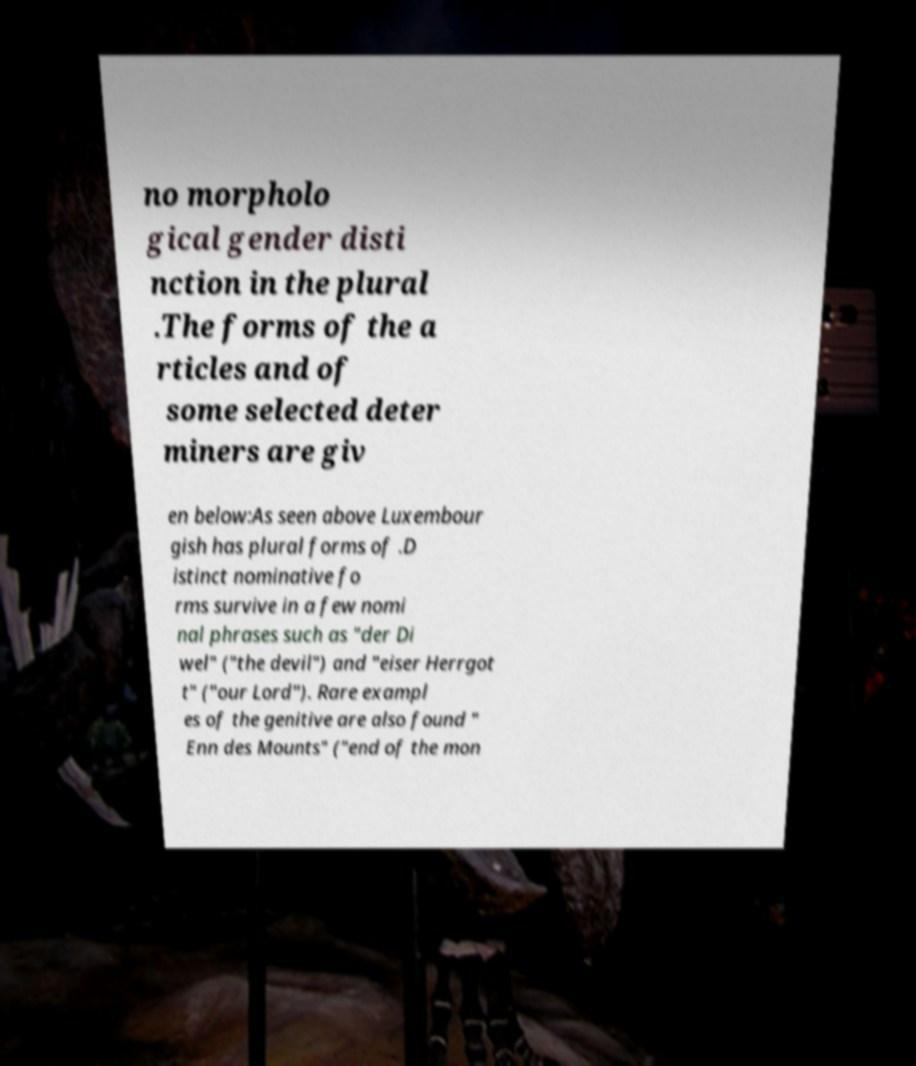What messages or text are displayed in this image? I need them in a readable, typed format. no morpholo gical gender disti nction in the plural .The forms of the a rticles and of some selected deter miners are giv en below:As seen above Luxembour gish has plural forms of .D istinct nominative fo rms survive in a few nomi nal phrases such as "der Di wel" ("the devil") and "eiser Herrgot t" ("our Lord"). Rare exampl es of the genitive are also found " Enn des Mounts" ("end of the mon 